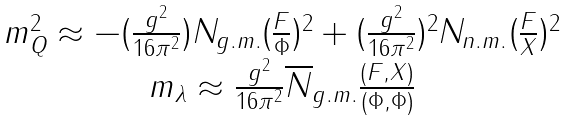Convert formula to latex. <formula><loc_0><loc_0><loc_500><loc_500>\begin{array} { c } m _ { Q } ^ { 2 } \approx - ( \frac { g ^ { 2 } } { 1 6 \pi ^ { 2 } } ) N _ { g . m . } ( \frac { F } { \Phi } ) ^ { 2 } + ( \frac { g ^ { 2 } } { 1 6 \pi ^ { 2 } } ) ^ { 2 } N _ { n . m . } ( \frac { F } { X } ) ^ { 2 } \\ m _ { \lambda } \approx \frac { g ^ { 2 } } { 1 6 \pi ^ { 2 } } \overline { N } _ { g . m . } \frac { ( F , X ) } { ( \Phi , \Phi ) } \end{array}</formula> 